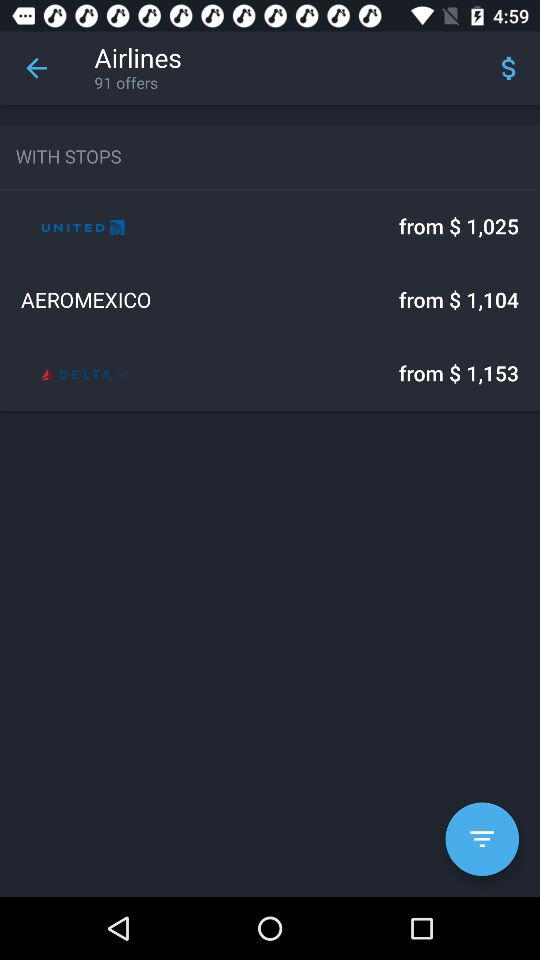How many offers are there? There are 91 offers. 